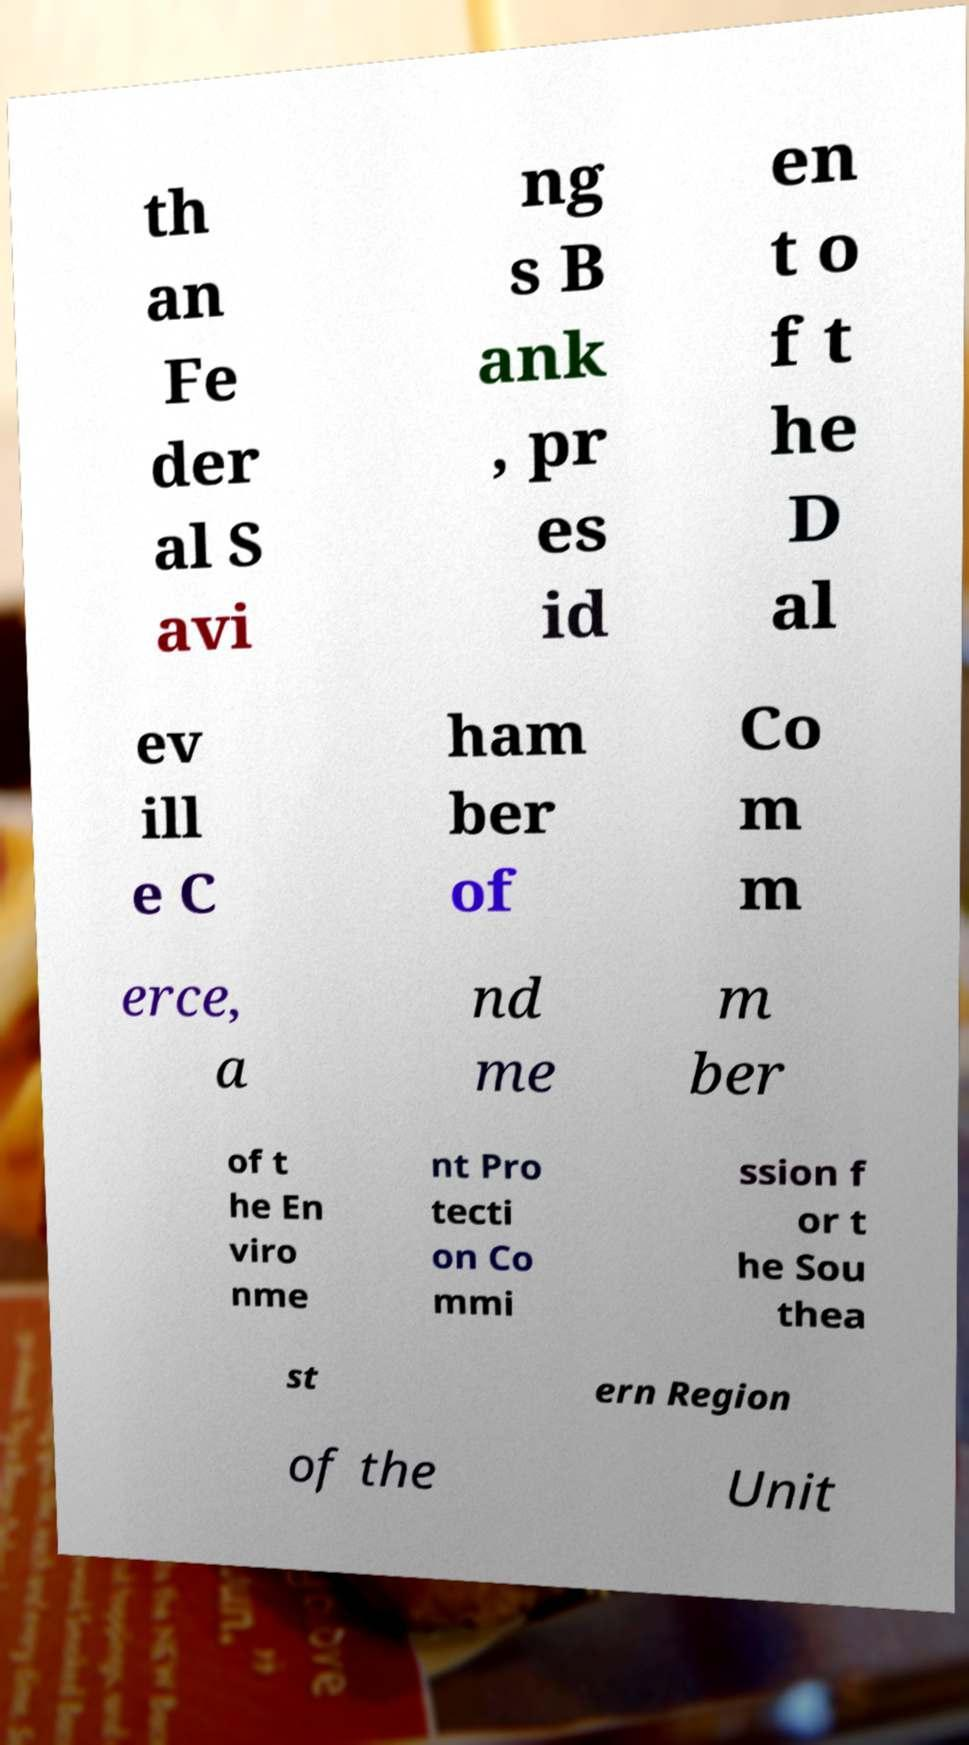Can you accurately transcribe the text from the provided image for me? th an Fe der al S avi ng s B ank , pr es id en t o f t he D al ev ill e C ham ber of Co m m erce, a nd me m ber of t he En viro nme nt Pro tecti on Co mmi ssion f or t he Sou thea st ern Region of the Unit 